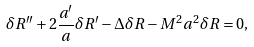<formula> <loc_0><loc_0><loc_500><loc_500>\delta R ^ { \prime \prime } + 2 \frac { a ^ { \prime } } { a } \delta R ^ { \prime } - \Delta \delta R - M ^ { 2 } a ^ { 2 } \delta R = 0 ,</formula> 